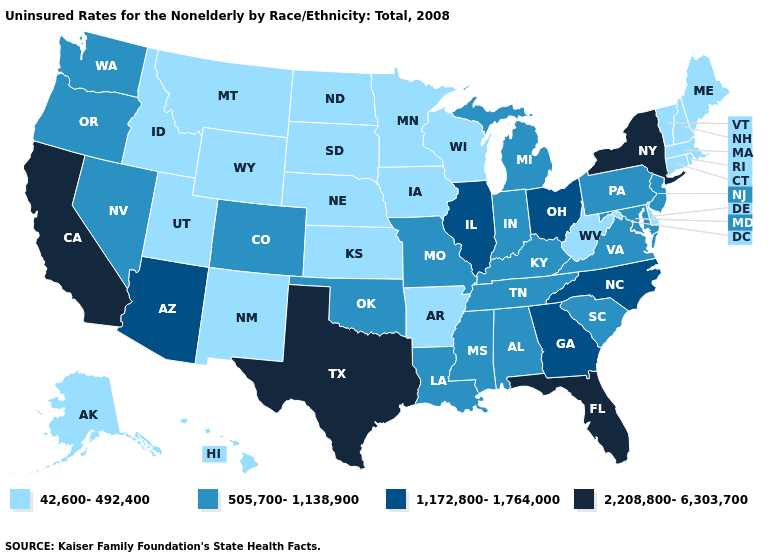How many symbols are there in the legend?
Short answer required. 4. What is the lowest value in the Northeast?
Give a very brief answer. 42,600-492,400. Does Florida have the highest value in the USA?
Write a very short answer. Yes. What is the lowest value in the USA?
Keep it brief. 42,600-492,400. How many symbols are there in the legend?
Write a very short answer. 4. Does Louisiana have the highest value in the USA?
Short answer required. No. Name the states that have a value in the range 1,172,800-1,764,000?
Concise answer only. Arizona, Georgia, Illinois, North Carolina, Ohio. What is the lowest value in the USA?
Answer briefly. 42,600-492,400. Name the states that have a value in the range 42,600-492,400?
Short answer required. Alaska, Arkansas, Connecticut, Delaware, Hawaii, Idaho, Iowa, Kansas, Maine, Massachusetts, Minnesota, Montana, Nebraska, New Hampshire, New Mexico, North Dakota, Rhode Island, South Dakota, Utah, Vermont, West Virginia, Wisconsin, Wyoming. What is the value of Kansas?
Concise answer only. 42,600-492,400. What is the value of Alabama?
Be succinct. 505,700-1,138,900. What is the value of South Dakota?
Keep it brief. 42,600-492,400. Name the states that have a value in the range 505,700-1,138,900?
Write a very short answer. Alabama, Colorado, Indiana, Kentucky, Louisiana, Maryland, Michigan, Mississippi, Missouri, Nevada, New Jersey, Oklahoma, Oregon, Pennsylvania, South Carolina, Tennessee, Virginia, Washington. Which states have the highest value in the USA?
Answer briefly. California, Florida, New York, Texas. What is the lowest value in the South?
Quick response, please. 42,600-492,400. 